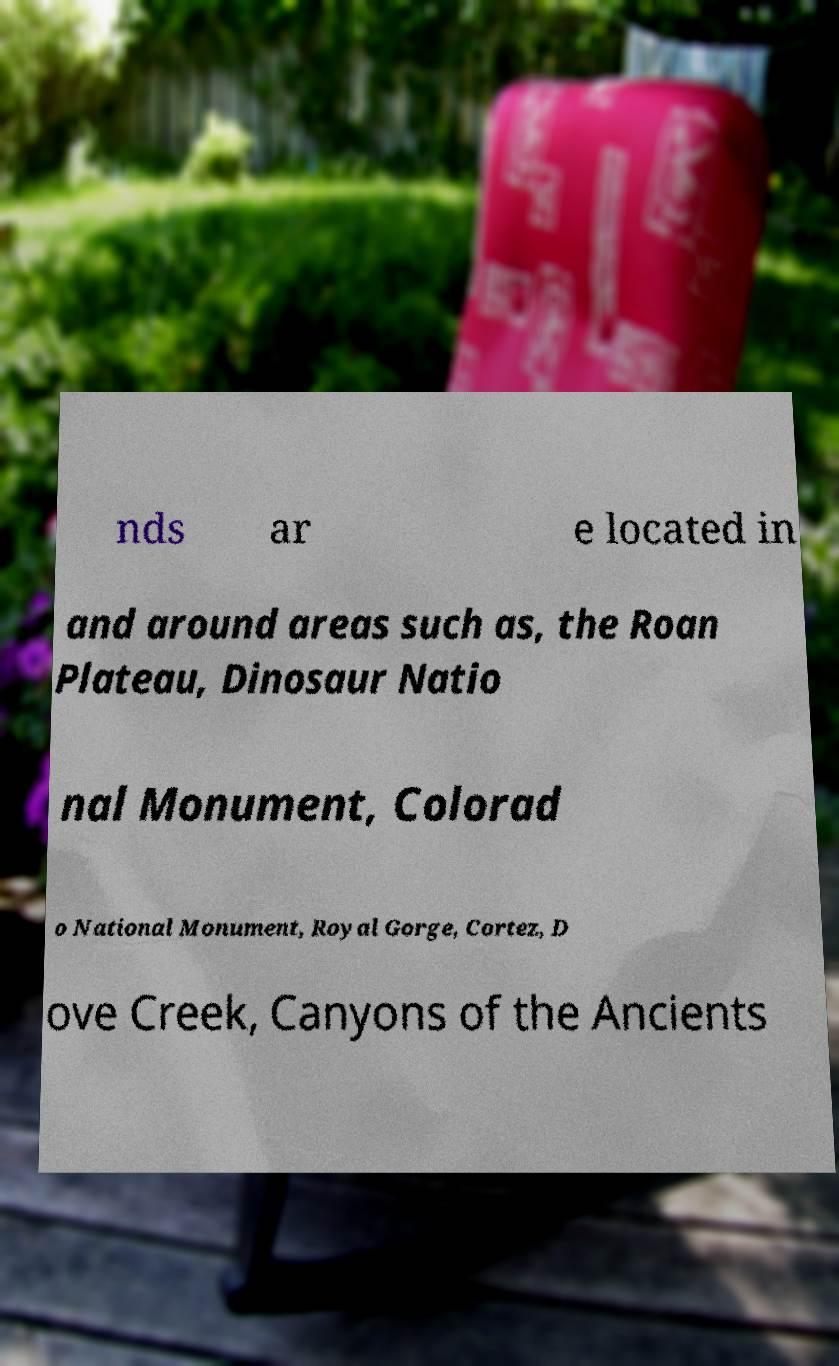Can you read and provide the text displayed in the image?This photo seems to have some interesting text. Can you extract and type it out for me? nds ar e located in and around areas such as, the Roan Plateau, Dinosaur Natio nal Monument, Colorad o National Monument, Royal Gorge, Cortez, D ove Creek, Canyons of the Ancients 